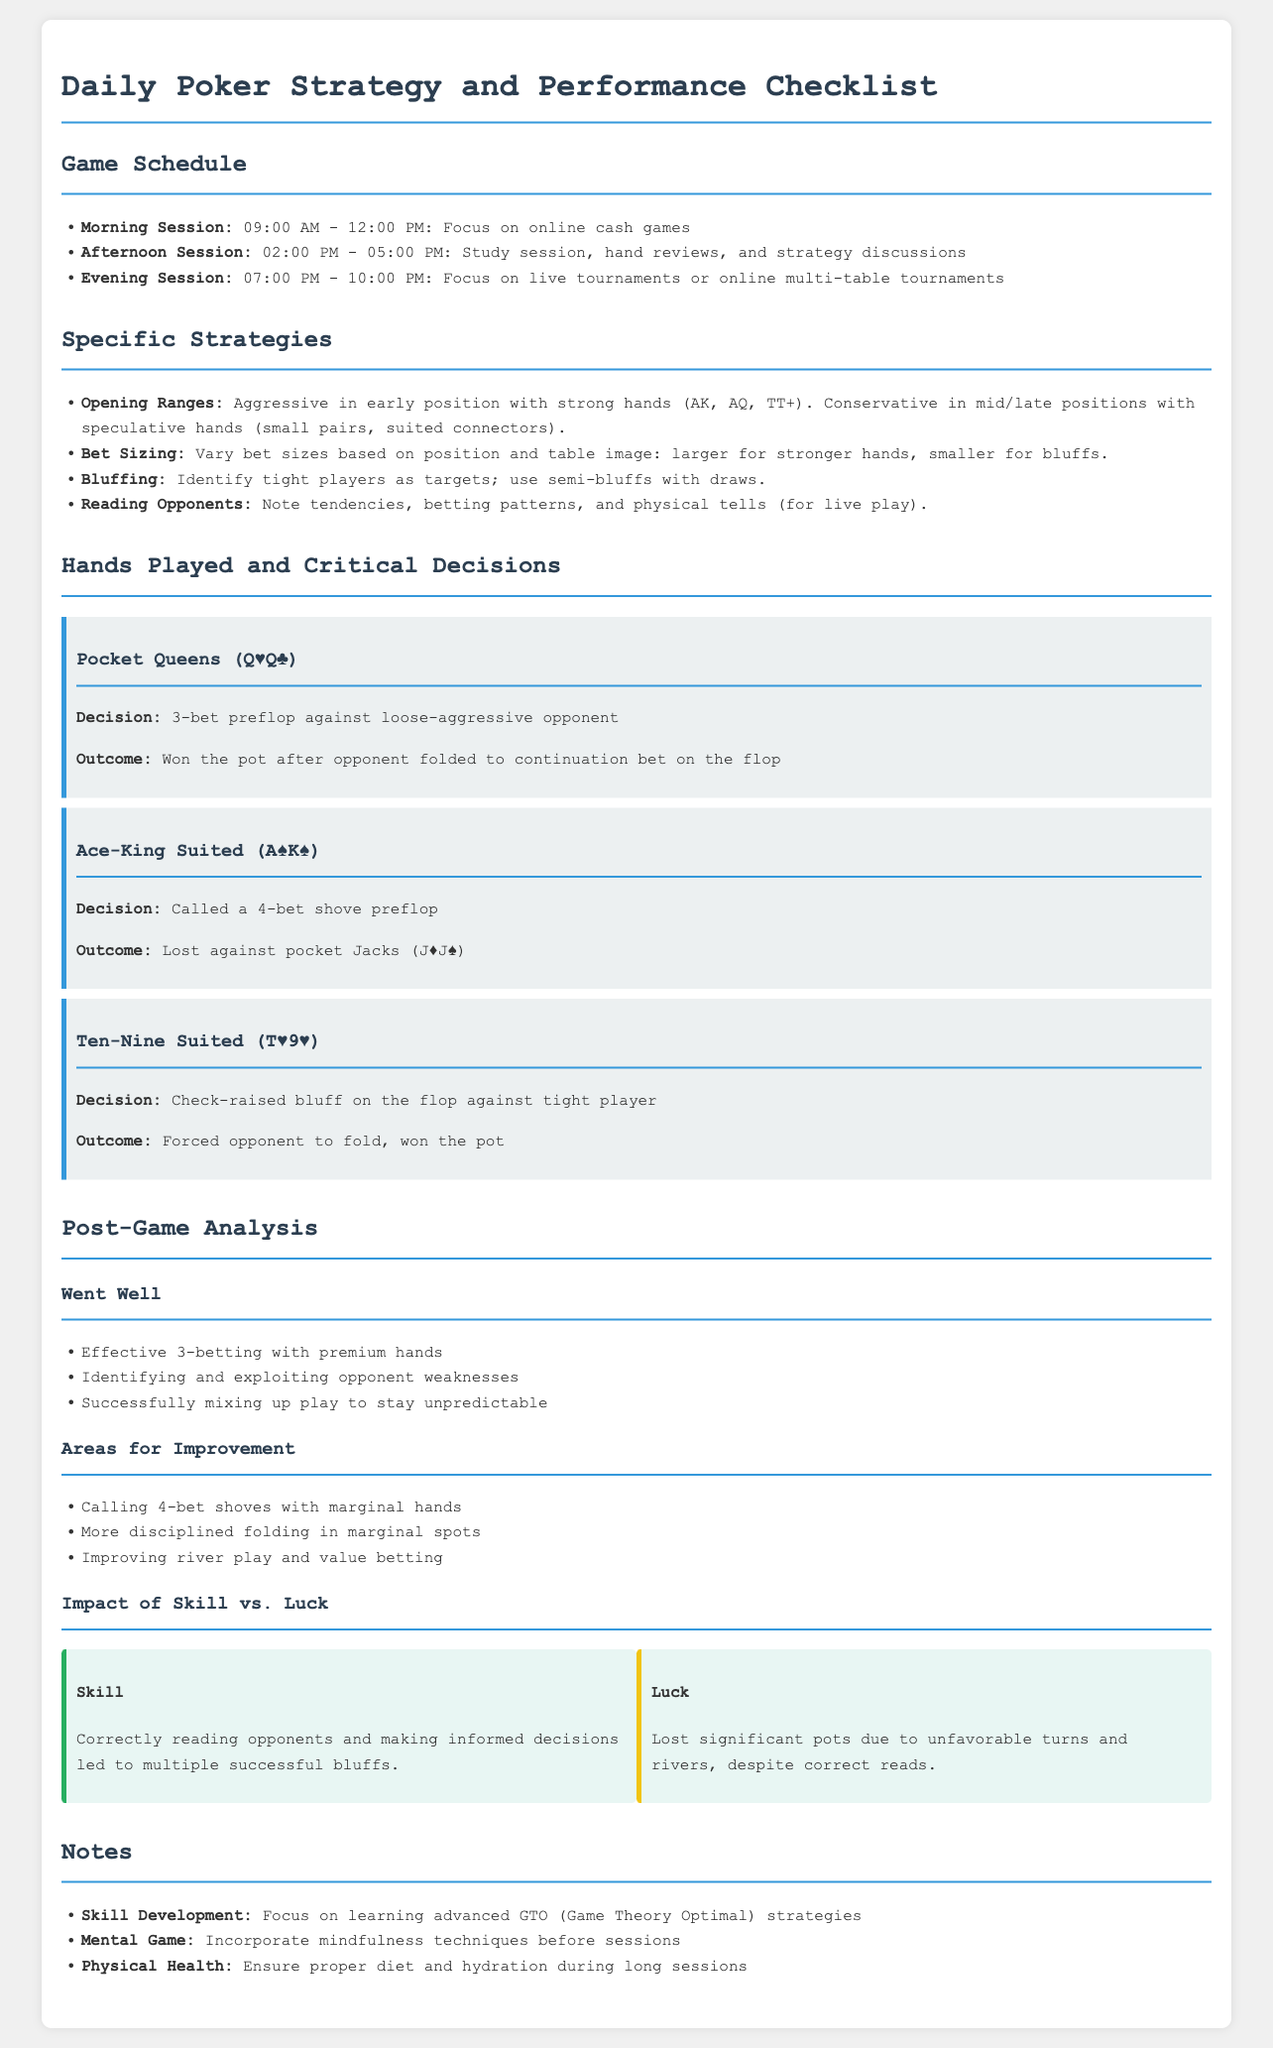What time does the morning session start? The morning session starts at 09:00 AM, which is mentioned in the game schedule.
Answer: 09:00 AM What is the main strategy for bluffing? The strategy involves identifying tight players as targets and using semi-bluffs with draws, detailed in the specific strategies section.
Answer: Identify tight players; use semi-bluffs with draws How many hands played are documented? There are three specific hands detailed in the hands played and critical decisions section.
Answer: Three What was the outcome of the Pocket Queens hand? The outcome of the Pocket Queens hand is documented as "Won the pot after opponent folded to continuation bet on the flop."
Answer: Won the pot Which area requires improvement according to the analysis? The analysis indicates that calling 4-bet shoves with marginal hands is one area for improvement.
Answer: Calling 4-bet shoves with marginal hands What was the impact of skill in the session? The document states that correctly reading opponents and making informed decisions led to successful bluffs, indicating skill's impact.
Answer: Correctly reading opponents What is the recommended focus for skill development? Skill development is recommended to focus on learning advanced GTO strategies as noted in the notes section.
Answer: Advanced GTO strategies What time does the afternoon study session start? The afternoon study session starts at 02:00 PM according to the game schedule.
Answer: 02:00 PM What are the two aspects compared in the impact of skill versus luck section? The section compares 'Skill' and 'Luck' to highlight their roles during the session.
Answer: Skill and Luck 